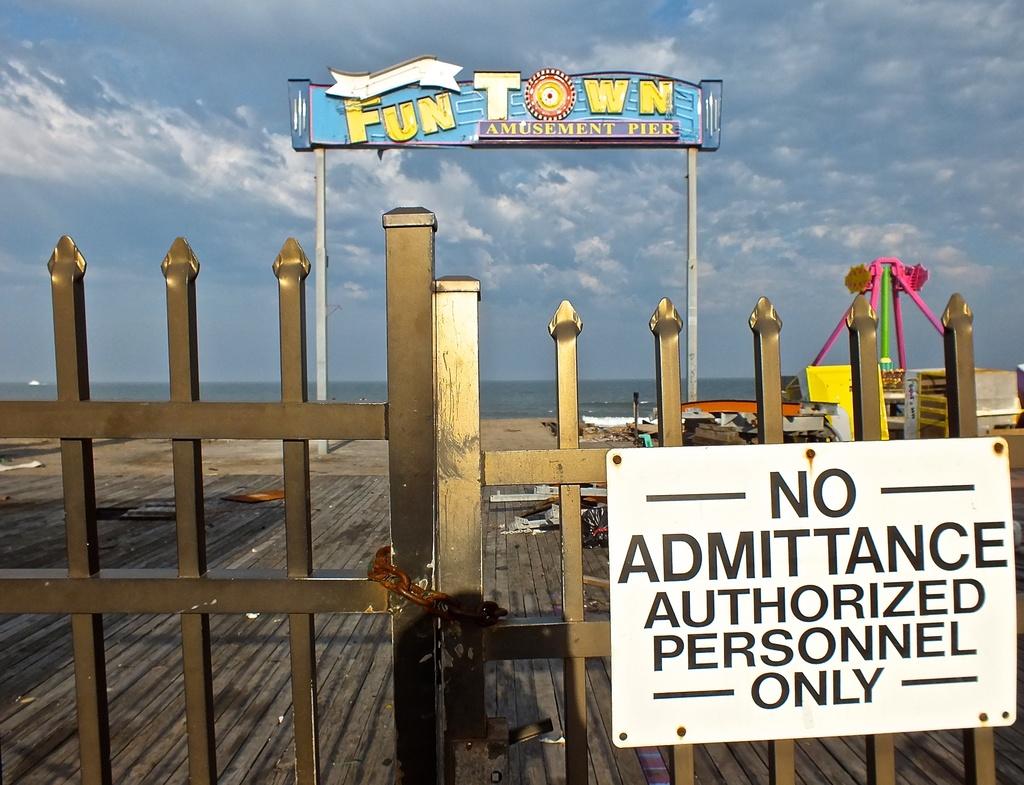What is the name of this park?
Ensure brevity in your answer.  Fun town. 